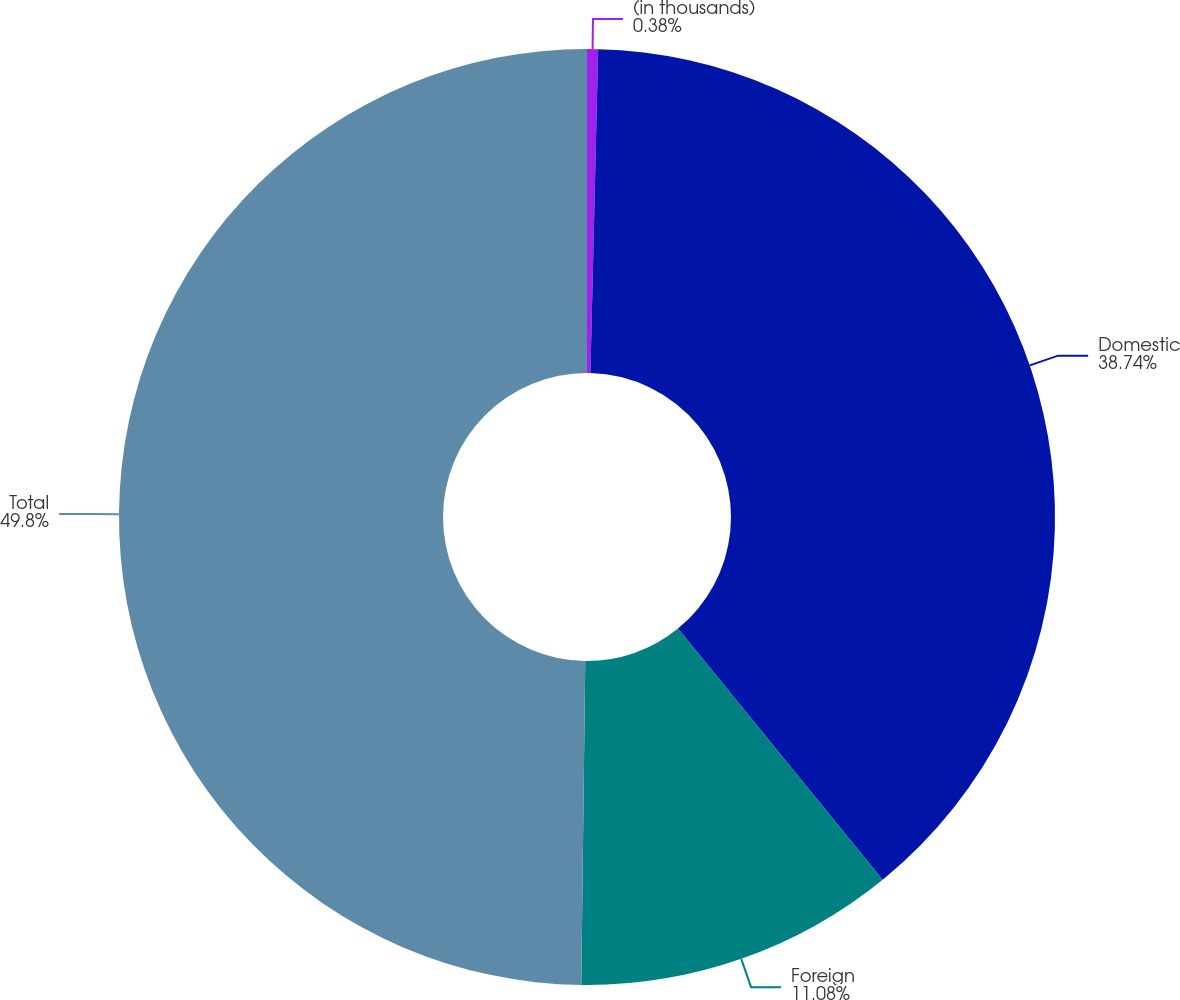Convert chart to OTSL. <chart><loc_0><loc_0><loc_500><loc_500><pie_chart><fcel>(in thousands)<fcel>Domestic<fcel>Foreign<fcel>Total<nl><fcel>0.38%<fcel>38.74%<fcel>11.08%<fcel>49.81%<nl></chart> 